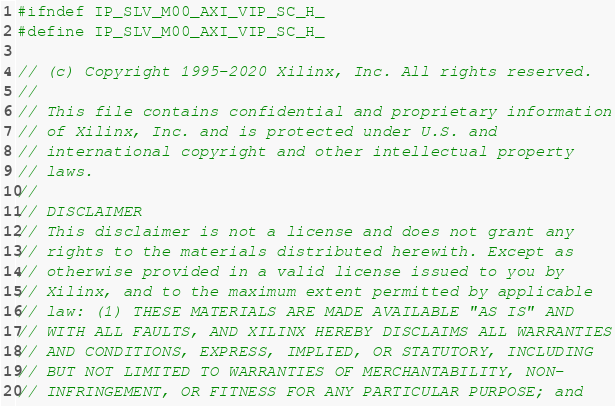Convert code to text. <code><loc_0><loc_0><loc_500><loc_500><_C_>#ifndef IP_SLV_M00_AXI_VIP_SC_H_
#define IP_SLV_M00_AXI_VIP_SC_H_

// (c) Copyright 1995-2020 Xilinx, Inc. All rights reserved.
// 
// This file contains confidential and proprietary information
// of Xilinx, Inc. and is protected under U.S. and
// international copyright and other intellectual property
// laws.
// 
// DISCLAIMER
// This disclaimer is not a license and does not grant any
// rights to the materials distributed herewith. Except as
// otherwise provided in a valid license issued to you by
// Xilinx, and to the maximum extent permitted by applicable
// law: (1) THESE MATERIALS ARE MADE AVAILABLE "AS IS" AND
// WITH ALL FAULTS, AND XILINX HEREBY DISCLAIMS ALL WARRANTIES
// AND CONDITIONS, EXPRESS, IMPLIED, OR STATUTORY, INCLUDING
// BUT NOT LIMITED TO WARRANTIES OF MERCHANTABILITY, NON-
// INFRINGEMENT, OR FITNESS FOR ANY PARTICULAR PURPOSE; and</code> 